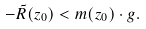Convert formula to latex. <formula><loc_0><loc_0><loc_500><loc_500>- \tilde { R } ( z _ { 0 } ) < m ( z _ { 0 } ) \cdot g .</formula> 